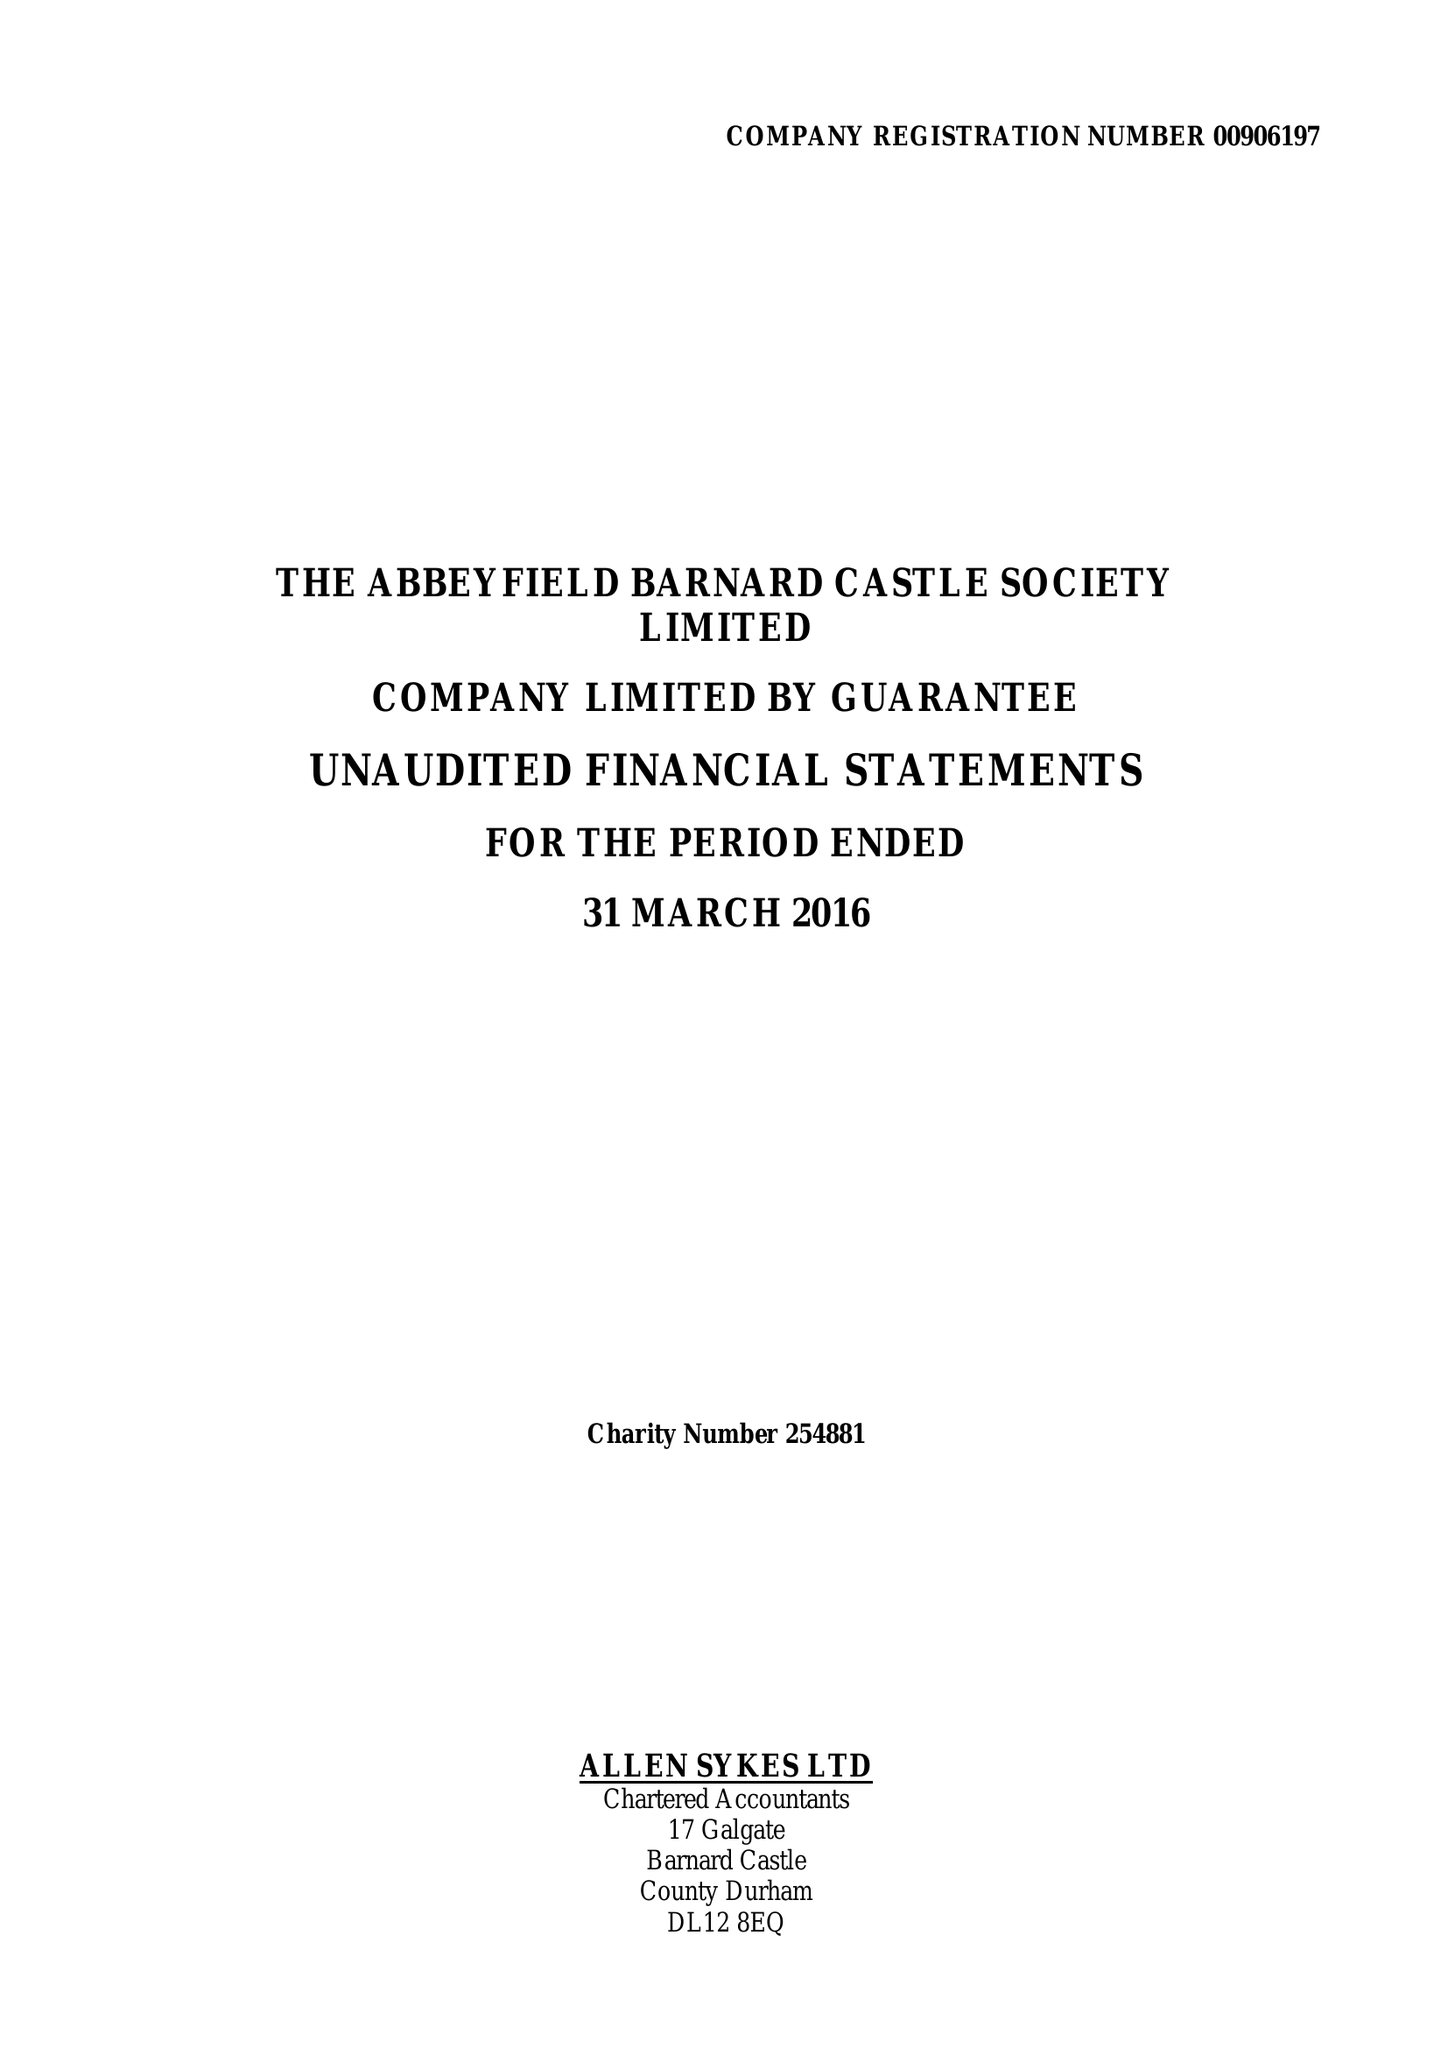What is the value for the address__street_line?
Answer the question using a single word or phrase. None 